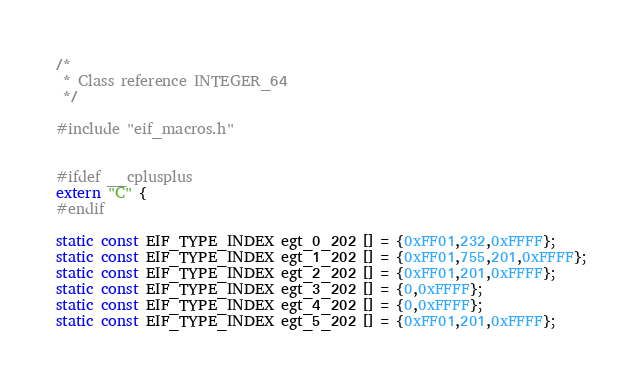<code> <loc_0><loc_0><loc_500><loc_500><_C_>/*
 * Class reference INTEGER_64
 */

#include "eif_macros.h"


#ifdef __cplusplus
extern "C" {
#endif

static const EIF_TYPE_INDEX egt_0_202 [] = {0xFF01,232,0xFFFF};
static const EIF_TYPE_INDEX egt_1_202 [] = {0xFF01,755,201,0xFFFF};
static const EIF_TYPE_INDEX egt_2_202 [] = {0xFF01,201,0xFFFF};
static const EIF_TYPE_INDEX egt_3_202 [] = {0,0xFFFF};
static const EIF_TYPE_INDEX egt_4_202 [] = {0,0xFFFF};
static const EIF_TYPE_INDEX egt_5_202 [] = {0xFF01,201,0xFFFF};</code> 